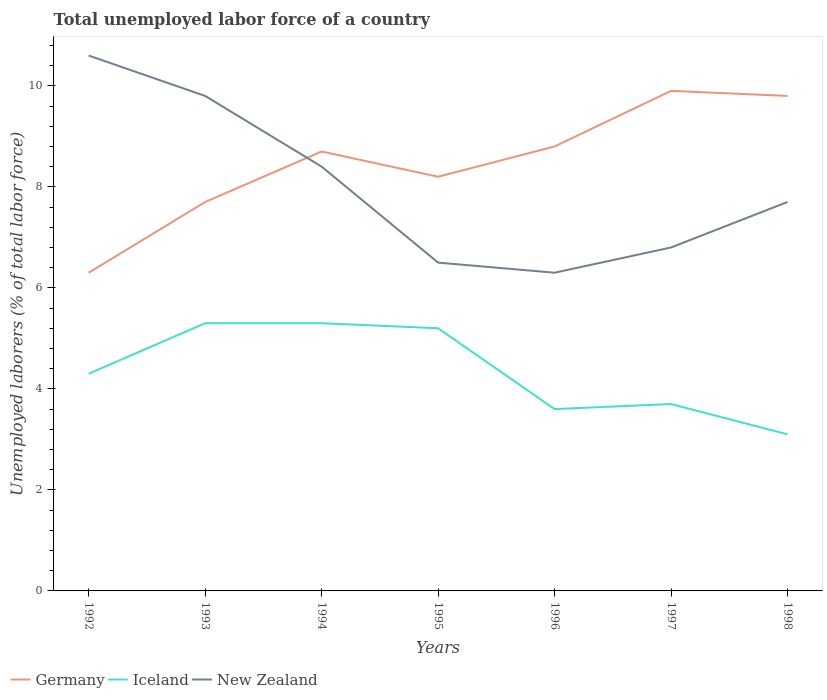Does the line corresponding to Iceland intersect with the line corresponding to New Zealand?
Make the answer very short. No. Is the number of lines equal to the number of legend labels?
Keep it short and to the point. Yes. Across all years, what is the maximum total unemployed labor force in Iceland?
Your response must be concise. 3.1. In which year was the total unemployed labor force in New Zealand maximum?
Your response must be concise. 1996. What is the difference between the highest and the second highest total unemployed labor force in Germany?
Give a very brief answer. 3.6. Is the total unemployed labor force in Germany strictly greater than the total unemployed labor force in New Zealand over the years?
Keep it short and to the point. No. How many years are there in the graph?
Your answer should be very brief. 7. Does the graph contain any zero values?
Your response must be concise. No. How many legend labels are there?
Make the answer very short. 3. How are the legend labels stacked?
Ensure brevity in your answer.  Horizontal. What is the title of the graph?
Give a very brief answer. Total unemployed labor force of a country. What is the label or title of the X-axis?
Offer a terse response. Years. What is the label or title of the Y-axis?
Offer a terse response. Unemployed laborers (% of total labor force). What is the Unemployed laborers (% of total labor force) of Germany in 1992?
Make the answer very short. 6.3. What is the Unemployed laborers (% of total labor force) of Iceland in 1992?
Your answer should be very brief. 4.3. What is the Unemployed laborers (% of total labor force) in New Zealand in 1992?
Your answer should be very brief. 10.6. What is the Unemployed laborers (% of total labor force) of Germany in 1993?
Offer a terse response. 7.7. What is the Unemployed laborers (% of total labor force) of Iceland in 1993?
Your response must be concise. 5.3. What is the Unemployed laborers (% of total labor force) of New Zealand in 1993?
Offer a terse response. 9.8. What is the Unemployed laborers (% of total labor force) in Germany in 1994?
Ensure brevity in your answer.  8.7. What is the Unemployed laborers (% of total labor force) of Iceland in 1994?
Give a very brief answer. 5.3. What is the Unemployed laborers (% of total labor force) of New Zealand in 1994?
Provide a short and direct response. 8.4. What is the Unemployed laborers (% of total labor force) in Germany in 1995?
Give a very brief answer. 8.2. What is the Unemployed laborers (% of total labor force) of Iceland in 1995?
Offer a very short reply. 5.2. What is the Unemployed laborers (% of total labor force) in Germany in 1996?
Your response must be concise. 8.8. What is the Unemployed laborers (% of total labor force) in Iceland in 1996?
Your answer should be compact. 3.6. What is the Unemployed laborers (% of total labor force) of New Zealand in 1996?
Provide a succinct answer. 6.3. What is the Unemployed laborers (% of total labor force) of Germany in 1997?
Make the answer very short. 9.9. What is the Unemployed laborers (% of total labor force) in Iceland in 1997?
Your answer should be compact. 3.7. What is the Unemployed laborers (% of total labor force) in New Zealand in 1997?
Offer a terse response. 6.8. What is the Unemployed laborers (% of total labor force) of Germany in 1998?
Your answer should be very brief. 9.8. What is the Unemployed laborers (% of total labor force) of Iceland in 1998?
Your answer should be compact. 3.1. What is the Unemployed laborers (% of total labor force) in New Zealand in 1998?
Make the answer very short. 7.7. Across all years, what is the maximum Unemployed laborers (% of total labor force) of Germany?
Keep it short and to the point. 9.9. Across all years, what is the maximum Unemployed laborers (% of total labor force) of Iceland?
Give a very brief answer. 5.3. Across all years, what is the maximum Unemployed laborers (% of total labor force) of New Zealand?
Your answer should be very brief. 10.6. Across all years, what is the minimum Unemployed laborers (% of total labor force) in Germany?
Ensure brevity in your answer.  6.3. Across all years, what is the minimum Unemployed laborers (% of total labor force) of Iceland?
Your answer should be compact. 3.1. Across all years, what is the minimum Unemployed laborers (% of total labor force) in New Zealand?
Your answer should be compact. 6.3. What is the total Unemployed laborers (% of total labor force) in Germany in the graph?
Your response must be concise. 59.4. What is the total Unemployed laborers (% of total labor force) of Iceland in the graph?
Ensure brevity in your answer.  30.5. What is the total Unemployed laborers (% of total labor force) in New Zealand in the graph?
Give a very brief answer. 56.1. What is the difference between the Unemployed laborers (% of total labor force) in Germany in 1992 and that in 1993?
Provide a succinct answer. -1.4. What is the difference between the Unemployed laborers (% of total labor force) of Iceland in 1992 and that in 1993?
Your answer should be very brief. -1. What is the difference between the Unemployed laborers (% of total labor force) in Germany in 1992 and that in 1994?
Your response must be concise. -2.4. What is the difference between the Unemployed laborers (% of total labor force) of Iceland in 1992 and that in 1994?
Keep it short and to the point. -1. What is the difference between the Unemployed laborers (% of total labor force) of Germany in 1992 and that in 1995?
Provide a short and direct response. -1.9. What is the difference between the Unemployed laborers (% of total labor force) in New Zealand in 1992 and that in 1996?
Your response must be concise. 4.3. What is the difference between the Unemployed laborers (% of total labor force) in Germany in 1992 and that in 1997?
Your answer should be compact. -3.6. What is the difference between the Unemployed laborers (% of total labor force) of New Zealand in 1992 and that in 1997?
Your answer should be very brief. 3.8. What is the difference between the Unemployed laborers (% of total labor force) of Germany in 1992 and that in 1998?
Make the answer very short. -3.5. What is the difference between the Unemployed laborers (% of total labor force) of Germany in 1993 and that in 1994?
Offer a very short reply. -1. What is the difference between the Unemployed laborers (% of total labor force) of Iceland in 1993 and that in 1994?
Provide a short and direct response. 0. What is the difference between the Unemployed laborers (% of total labor force) of New Zealand in 1993 and that in 1994?
Offer a very short reply. 1.4. What is the difference between the Unemployed laborers (% of total labor force) in Iceland in 1993 and that in 1995?
Offer a terse response. 0.1. What is the difference between the Unemployed laborers (% of total labor force) of Germany in 1993 and that in 1997?
Offer a terse response. -2.2. What is the difference between the Unemployed laborers (% of total labor force) of Iceland in 1993 and that in 1997?
Your answer should be very brief. 1.6. What is the difference between the Unemployed laborers (% of total labor force) of New Zealand in 1993 and that in 1997?
Your answer should be compact. 3. What is the difference between the Unemployed laborers (% of total labor force) in Germany in 1994 and that in 1995?
Provide a succinct answer. 0.5. What is the difference between the Unemployed laborers (% of total labor force) in Iceland in 1994 and that in 1995?
Provide a short and direct response. 0.1. What is the difference between the Unemployed laborers (% of total labor force) of Iceland in 1994 and that in 1996?
Make the answer very short. 1.7. What is the difference between the Unemployed laborers (% of total labor force) of New Zealand in 1994 and that in 1996?
Keep it short and to the point. 2.1. What is the difference between the Unemployed laborers (% of total labor force) in Germany in 1994 and that in 1997?
Provide a succinct answer. -1.2. What is the difference between the Unemployed laborers (% of total labor force) in Iceland in 1994 and that in 1997?
Your answer should be compact. 1.6. What is the difference between the Unemployed laborers (% of total labor force) of Iceland in 1994 and that in 1998?
Your answer should be compact. 2.2. What is the difference between the Unemployed laborers (% of total labor force) of Iceland in 1995 and that in 1996?
Your response must be concise. 1.6. What is the difference between the Unemployed laborers (% of total labor force) of Iceland in 1995 and that in 1997?
Your answer should be very brief. 1.5. What is the difference between the Unemployed laborers (% of total labor force) of New Zealand in 1995 and that in 1997?
Your answer should be very brief. -0.3. What is the difference between the Unemployed laborers (% of total labor force) in Iceland in 1995 and that in 1998?
Your response must be concise. 2.1. What is the difference between the Unemployed laborers (% of total labor force) in New Zealand in 1995 and that in 1998?
Provide a short and direct response. -1.2. What is the difference between the Unemployed laborers (% of total labor force) of New Zealand in 1996 and that in 1997?
Your answer should be very brief. -0.5. What is the difference between the Unemployed laborers (% of total labor force) in New Zealand in 1996 and that in 1998?
Your answer should be compact. -1.4. What is the difference between the Unemployed laborers (% of total labor force) in Germany in 1997 and that in 1998?
Keep it short and to the point. 0.1. What is the difference between the Unemployed laborers (% of total labor force) of New Zealand in 1997 and that in 1998?
Your answer should be compact. -0.9. What is the difference between the Unemployed laborers (% of total labor force) of Germany in 1992 and the Unemployed laborers (% of total labor force) of New Zealand in 1993?
Provide a succinct answer. -3.5. What is the difference between the Unemployed laborers (% of total labor force) of Germany in 1992 and the Unemployed laborers (% of total labor force) of Iceland in 1995?
Keep it short and to the point. 1.1. What is the difference between the Unemployed laborers (% of total labor force) in Germany in 1992 and the Unemployed laborers (% of total labor force) in New Zealand in 1995?
Your answer should be very brief. -0.2. What is the difference between the Unemployed laborers (% of total labor force) of Germany in 1992 and the Unemployed laborers (% of total labor force) of Iceland in 1996?
Offer a terse response. 2.7. What is the difference between the Unemployed laborers (% of total labor force) in Germany in 1992 and the Unemployed laborers (% of total labor force) in New Zealand in 1996?
Your answer should be compact. 0. What is the difference between the Unemployed laborers (% of total labor force) of Iceland in 1992 and the Unemployed laborers (% of total labor force) of New Zealand in 1996?
Provide a short and direct response. -2. What is the difference between the Unemployed laborers (% of total labor force) in Germany in 1992 and the Unemployed laborers (% of total labor force) in Iceland in 1997?
Your answer should be very brief. 2.6. What is the difference between the Unemployed laborers (% of total labor force) in Germany in 1992 and the Unemployed laborers (% of total labor force) in New Zealand in 1997?
Keep it short and to the point. -0.5. What is the difference between the Unemployed laborers (% of total labor force) of Iceland in 1992 and the Unemployed laborers (% of total labor force) of New Zealand in 1997?
Keep it short and to the point. -2.5. What is the difference between the Unemployed laborers (% of total labor force) of Germany in 1992 and the Unemployed laborers (% of total labor force) of New Zealand in 1998?
Offer a very short reply. -1.4. What is the difference between the Unemployed laborers (% of total labor force) of Germany in 1993 and the Unemployed laborers (% of total labor force) of Iceland in 1995?
Offer a terse response. 2.5. What is the difference between the Unemployed laborers (% of total labor force) in Germany in 1993 and the Unemployed laborers (% of total labor force) in New Zealand in 1995?
Ensure brevity in your answer.  1.2. What is the difference between the Unemployed laborers (% of total labor force) of Germany in 1993 and the Unemployed laborers (% of total labor force) of Iceland in 1996?
Your response must be concise. 4.1. What is the difference between the Unemployed laborers (% of total labor force) of Germany in 1993 and the Unemployed laborers (% of total labor force) of New Zealand in 1996?
Your answer should be compact. 1.4. What is the difference between the Unemployed laborers (% of total labor force) of Iceland in 1993 and the Unemployed laborers (% of total labor force) of New Zealand in 1996?
Make the answer very short. -1. What is the difference between the Unemployed laborers (% of total labor force) of Germany in 1993 and the Unemployed laborers (% of total labor force) of New Zealand in 1998?
Offer a very short reply. 0. What is the difference between the Unemployed laborers (% of total labor force) of Germany in 1994 and the Unemployed laborers (% of total labor force) of New Zealand in 1995?
Make the answer very short. 2.2. What is the difference between the Unemployed laborers (% of total labor force) in Germany in 1994 and the Unemployed laborers (% of total labor force) in Iceland in 1996?
Provide a short and direct response. 5.1. What is the difference between the Unemployed laborers (% of total labor force) in Germany in 1994 and the Unemployed laborers (% of total labor force) in New Zealand in 1996?
Give a very brief answer. 2.4. What is the difference between the Unemployed laborers (% of total labor force) in Iceland in 1994 and the Unemployed laborers (% of total labor force) in New Zealand in 1996?
Give a very brief answer. -1. What is the difference between the Unemployed laborers (% of total labor force) in Germany in 1994 and the Unemployed laborers (% of total labor force) in Iceland in 1997?
Give a very brief answer. 5. What is the difference between the Unemployed laborers (% of total labor force) of Germany in 1994 and the Unemployed laborers (% of total labor force) of New Zealand in 1997?
Provide a short and direct response. 1.9. What is the difference between the Unemployed laborers (% of total labor force) in Iceland in 1994 and the Unemployed laborers (% of total labor force) in New Zealand in 1997?
Offer a terse response. -1.5. What is the difference between the Unemployed laborers (% of total labor force) in Germany in 1994 and the Unemployed laborers (% of total labor force) in New Zealand in 1998?
Your answer should be very brief. 1. What is the difference between the Unemployed laborers (% of total labor force) of Iceland in 1995 and the Unemployed laborers (% of total labor force) of New Zealand in 1996?
Your answer should be compact. -1.1. What is the difference between the Unemployed laborers (% of total labor force) in Germany in 1995 and the Unemployed laborers (% of total labor force) in Iceland in 1997?
Your answer should be very brief. 4.5. What is the difference between the Unemployed laborers (% of total labor force) of Iceland in 1995 and the Unemployed laborers (% of total labor force) of New Zealand in 1997?
Make the answer very short. -1.6. What is the difference between the Unemployed laborers (% of total labor force) in Germany in 1995 and the Unemployed laborers (% of total labor force) in Iceland in 1998?
Your answer should be very brief. 5.1. What is the difference between the Unemployed laborers (% of total labor force) of Iceland in 1995 and the Unemployed laborers (% of total labor force) of New Zealand in 1998?
Your answer should be compact. -2.5. What is the difference between the Unemployed laborers (% of total labor force) in Germany in 1997 and the Unemployed laborers (% of total labor force) in Iceland in 1998?
Provide a succinct answer. 6.8. What is the average Unemployed laborers (% of total labor force) in Germany per year?
Offer a terse response. 8.49. What is the average Unemployed laborers (% of total labor force) in Iceland per year?
Give a very brief answer. 4.36. What is the average Unemployed laborers (% of total labor force) of New Zealand per year?
Make the answer very short. 8.01. In the year 1992, what is the difference between the Unemployed laborers (% of total labor force) of Germany and Unemployed laborers (% of total labor force) of Iceland?
Provide a succinct answer. 2. In the year 1992, what is the difference between the Unemployed laborers (% of total labor force) of Germany and Unemployed laborers (% of total labor force) of New Zealand?
Ensure brevity in your answer.  -4.3. In the year 1993, what is the difference between the Unemployed laborers (% of total labor force) of Germany and Unemployed laborers (% of total labor force) of New Zealand?
Keep it short and to the point. -2.1. In the year 1993, what is the difference between the Unemployed laborers (% of total labor force) in Iceland and Unemployed laborers (% of total labor force) in New Zealand?
Your answer should be very brief. -4.5. In the year 1994, what is the difference between the Unemployed laborers (% of total labor force) in Germany and Unemployed laborers (% of total labor force) in Iceland?
Offer a terse response. 3.4. In the year 1995, what is the difference between the Unemployed laborers (% of total labor force) in Germany and Unemployed laborers (% of total labor force) in Iceland?
Offer a terse response. 3. In the year 1995, what is the difference between the Unemployed laborers (% of total labor force) of Germany and Unemployed laborers (% of total labor force) of New Zealand?
Your answer should be very brief. 1.7. In the year 1995, what is the difference between the Unemployed laborers (% of total labor force) in Iceland and Unemployed laborers (% of total labor force) in New Zealand?
Give a very brief answer. -1.3. In the year 1996, what is the difference between the Unemployed laborers (% of total labor force) of Germany and Unemployed laborers (% of total labor force) of Iceland?
Ensure brevity in your answer.  5.2. In the year 1997, what is the difference between the Unemployed laborers (% of total labor force) in Germany and Unemployed laborers (% of total labor force) in Iceland?
Make the answer very short. 6.2. In the year 1997, what is the difference between the Unemployed laborers (% of total labor force) of Iceland and Unemployed laborers (% of total labor force) of New Zealand?
Offer a very short reply. -3.1. In the year 1998, what is the difference between the Unemployed laborers (% of total labor force) of Germany and Unemployed laborers (% of total labor force) of Iceland?
Offer a terse response. 6.7. What is the ratio of the Unemployed laborers (% of total labor force) of Germany in 1992 to that in 1993?
Offer a very short reply. 0.82. What is the ratio of the Unemployed laborers (% of total labor force) in Iceland in 1992 to that in 1993?
Your answer should be compact. 0.81. What is the ratio of the Unemployed laborers (% of total labor force) in New Zealand in 1992 to that in 1993?
Keep it short and to the point. 1.08. What is the ratio of the Unemployed laborers (% of total labor force) of Germany in 1992 to that in 1994?
Your response must be concise. 0.72. What is the ratio of the Unemployed laborers (% of total labor force) of Iceland in 1992 to that in 1994?
Your answer should be very brief. 0.81. What is the ratio of the Unemployed laborers (% of total labor force) of New Zealand in 1992 to that in 1994?
Keep it short and to the point. 1.26. What is the ratio of the Unemployed laborers (% of total labor force) of Germany in 1992 to that in 1995?
Offer a terse response. 0.77. What is the ratio of the Unemployed laborers (% of total labor force) in Iceland in 1992 to that in 1995?
Your response must be concise. 0.83. What is the ratio of the Unemployed laborers (% of total labor force) in New Zealand in 1992 to that in 1995?
Give a very brief answer. 1.63. What is the ratio of the Unemployed laborers (% of total labor force) of Germany in 1992 to that in 1996?
Give a very brief answer. 0.72. What is the ratio of the Unemployed laborers (% of total labor force) in Iceland in 1992 to that in 1996?
Make the answer very short. 1.19. What is the ratio of the Unemployed laborers (% of total labor force) of New Zealand in 1992 to that in 1996?
Offer a very short reply. 1.68. What is the ratio of the Unemployed laborers (% of total labor force) in Germany in 1992 to that in 1997?
Give a very brief answer. 0.64. What is the ratio of the Unemployed laborers (% of total labor force) of Iceland in 1992 to that in 1997?
Offer a very short reply. 1.16. What is the ratio of the Unemployed laborers (% of total labor force) of New Zealand in 1992 to that in 1997?
Your answer should be compact. 1.56. What is the ratio of the Unemployed laborers (% of total labor force) in Germany in 1992 to that in 1998?
Offer a very short reply. 0.64. What is the ratio of the Unemployed laborers (% of total labor force) in Iceland in 1992 to that in 1998?
Provide a short and direct response. 1.39. What is the ratio of the Unemployed laborers (% of total labor force) in New Zealand in 1992 to that in 1998?
Offer a terse response. 1.38. What is the ratio of the Unemployed laborers (% of total labor force) of Germany in 1993 to that in 1994?
Your answer should be compact. 0.89. What is the ratio of the Unemployed laborers (% of total labor force) in Germany in 1993 to that in 1995?
Your answer should be very brief. 0.94. What is the ratio of the Unemployed laborers (% of total labor force) of Iceland in 1993 to that in 1995?
Keep it short and to the point. 1.02. What is the ratio of the Unemployed laborers (% of total labor force) of New Zealand in 1993 to that in 1995?
Your response must be concise. 1.51. What is the ratio of the Unemployed laborers (% of total labor force) of Iceland in 1993 to that in 1996?
Your response must be concise. 1.47. What is the ratio of the Unemployed laborers (% of total labor force) in New Zealand in 1993 to that in 1996?
Provide a succinct answer. 1.56. What is the ratio of the Unemployed laborers (% of total labor force) in Germany in 1993 to that in 1997?
Keep it short and to the point. 0.78. What is the ratio of the Unemployed laborers (% of total labor force) in Iceland in 1993 to that in 1997?
Provide a short and direct response. 1.43. What is the ratio of the Unemployed laborers (% of total labor force) in New Zealand in 1993 to that in 1997?
Keep it short and to the point. 1.44. What is the ratio of the Unemployed laborers (% of total labor force) in Germany in 1993 to that in 1998?
Offer a very short reply. 0.79. What is the ratio of the Unemployed laborers (% of total labor force) of Iceland in 1993 to that in 1998?
Your answer should be compact. 1.71. What is the ratio of the Unemployed laborers (% of total labor force) in New Zealand in 1993 to that in 1998?
Your answer should be compact. 1.27. What is the ratio of the Unemployed laborers (% of total labor force) in Germany in 1994 to that in 1995?
Offer a very short reply. 1.06. What is the ratio of the Unemployed laborers (% of total labor force) in Iceland in 1994 to that in 1995?
Make the answer very short. 1.02. What is the ratio of the Unemployed laborers (% of total labor force) of New Zealand in 1994 to that in 1995?
Offer a very short reply. 1.29. What is the ratio of the Unemployed laborers (% of total labor force) of Iceland in 1994 to that in 1996?
Your answer should be compact. 1.47. What is the ratio of the Unemployed laborers (% of total labor force) of New Zealand in 1994 to that in 1996?
Make the answer very short. 1.33. What is the ratio of the Unemployed laborers (% of total labor force) in Germany in 1994 to that in 1997?
Offer a very short reply. 0.88. What is the ratio of the Unemployed laborers (% of total labor force) of Iceland in 1994 to that in 1997?
Offer a very short reply. 1.43. What is the ratio of the Unemployed laborers (% of total labor force) of New Zealand in 1994 to that in 1997?
Your answer should be compact. 1.24. What is the ratio of the Unemployed laborers (% of total labor force) of Germany in 1994 to that in 1998?
Your answer should be very brief. 0.89. What is the ratio of the Unemployed laborers (% of total labor force) of Iceland in 1994 to that in 1998?
Make the answer very short. 1.71. What is the ratio of the Unemployed laborers (% of total labor force) of New Zealand in 1994 to that in 1998?
Your answer should be compact. 1.09. What is the ratio of the Unemployed laborers (% of total labor force) in Germany in 1995 to that in 1996?
Give a very brief answer. 0.93. What is the ratio of the Unemployed laborers (% of total labor force) in Iceland in 1995 to that in 1996?
Your answer should be very brief. 1.44. What is the ratio of the Unemployed laborers (% of total labor force) of New Zealand in 1995 to that in 1996?
Give a very brief answer. 1.03. What is the ratio of the Unemployed laborers (% of total labor force) in Germany in 1995 to that in 1997?
Your response must be concise. 0.83. What is the ratio of the Unemployed laborers (% of total labor force) of Iceland in 1995 to that in 1997?
Your answer should be compact. 1.41. What is the ratio of the Unemployed laborers (% of total labor force) in New Zealand in 1995 to that in 1997?
Your response must be concise. 0.96. What is the ratio of the Unemployed laborers (% of total labor force) in Germany in 1995 to that in 1998?
Your answer should be compact. 0.84. What is the ratio of the Unemployed laborers (% of total labor force) in Iceland in 1995 to that in 1998?
Your answer should be compact. 1.68. What is the ratio of the Unemployed laborers (% of total labor force) in New Zealand in 1995 to that in 1998?
Offer a terse response. 0.84. What is the ratio of the Unemployed laborers (% of total labor force) in Germany in 1996 to that in 1997?
Keep it short and to the point. 0.89. What is the ratio of the Unemployed laborers (% of total labor force) of New Zealand in 1996 to that in 1997?
Your answer should be very brief. 0.93. What is the ratio of the Unemployed laborers (% of total labor force) of Germany in 1996 to that in 1998?
Provide a succinct answer. 0.9. What is the ratio of the Unemployed laborers (% of total labor force) in Iceland in 1996 to that in 1998?
Your answer should be compact. 1.16. What is the ratio of the Unemployed laborers (% of total labor force) of New Zealand in 1996 to that in 1998?
Ensure brevity in your answer.  0.82. What is the ratio of the Unemployed laborers (% of total labor force) in Germany in 1997 to that in 1998?
Your response must be concise. 1.01. What is the ratio of the Unemployed laborers (% of total labor force) of Iceland in 1997 to that in 1998?
Your answer should be compact. 1.19. What is the ratio of the Unemployed laborers (% of total labor force) in New Zealand in 1997 to that in 1998?
Ensure brevity in your answer.  0.88. What is the difference between the highest and the second highest Unemployed laborers (% of total labor force) in Germany?
Provide a succinct answer. 0.1. 